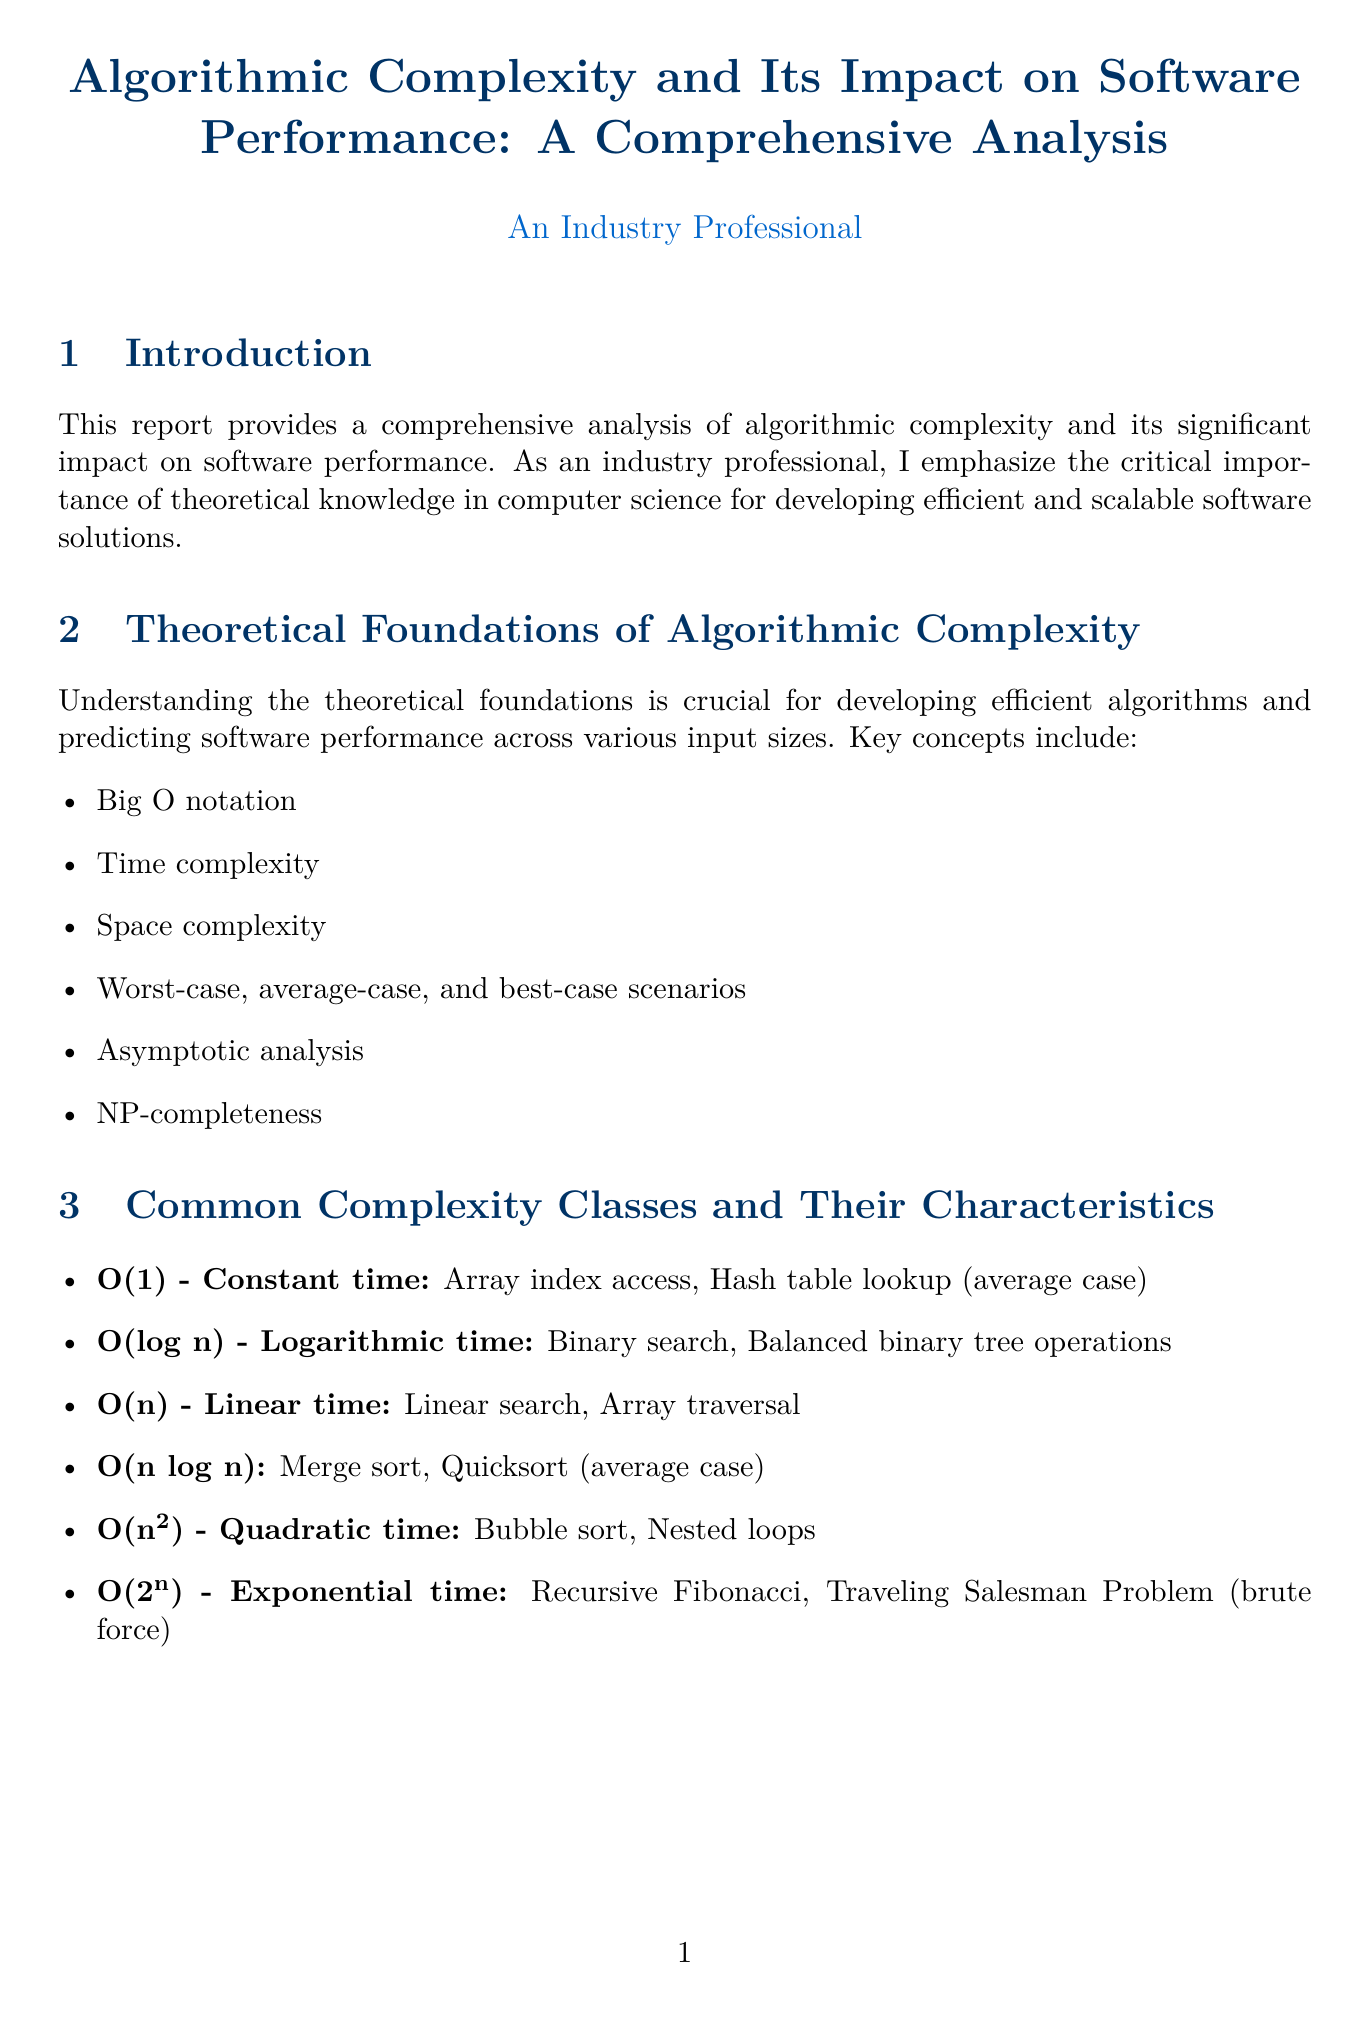What is the title of the report? The title is provided in the document header and describes the main focus of the report.
Answer: Algorithmic Complexity and Its Impact on Software Performance: A Comprehensive Analysis How many complexity classes are mentioned? The document lists different complexity classes under the section "Common Complexity Classes and Their Characteristics."
Answer: Six What is the complexity of Google's PageRank Algorithm? The complexity for Google's PageRank Algorithm is specified in the case studies section as part of its description.
Answer: O(n) Which benchmarking tool is used for microbenchmarking C++ code? The document explicitly mentions this benchmarking tool in the section on benchmarking techniques and tools.
Answer: Google Benchmark What is one of the best practices for optimizing algorithm efficiency? The document lists several practices that are important for improving algorithm efficiency.
Answer: Choose appropriate data structures What is the impact of algorithmic complexity on software performance? The factors affecting performance are outlined in the document to highlight its relevance.
Answer: Execution time, Memory usage, Scalability, Resource utilization, User experience Who authored "The Art of Computer Programming"? This academic reference is explicitly stated in the references section of the report.
Answer: Donald E. Knuth What sector is related to financial technology? The document categorizes various sectors where algorithmic complexity is relevant, including specific sectors.
Answer: Financial technology 